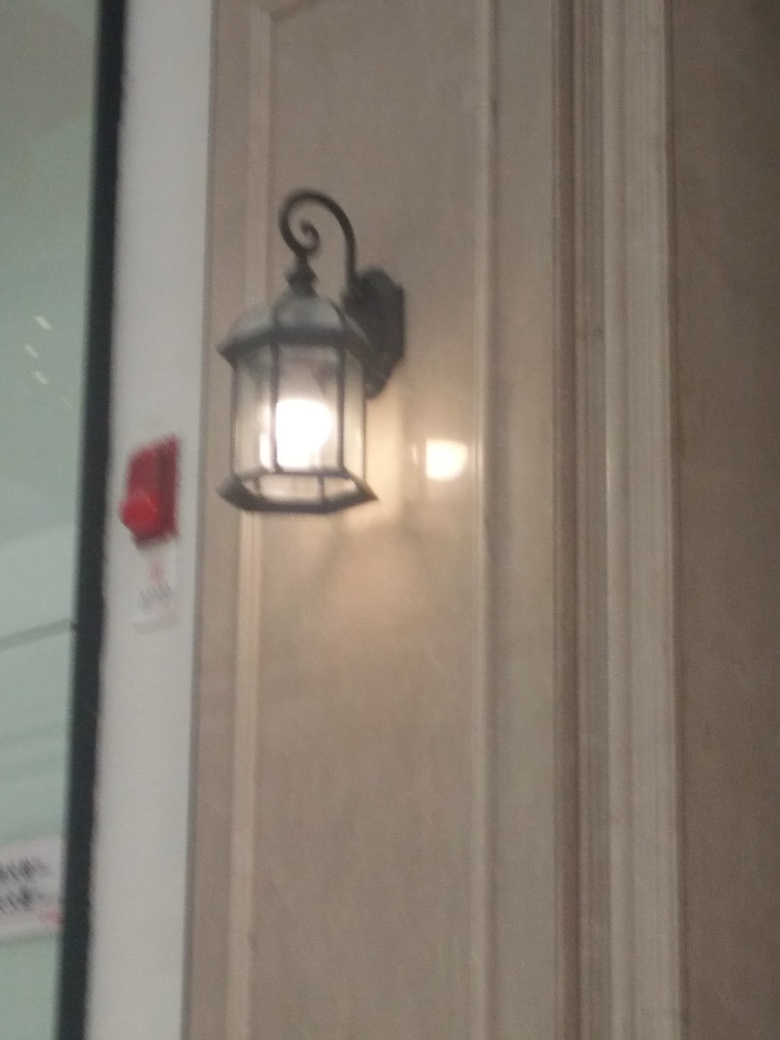Can you describe the style or era this lamp design might be from? The lamp has a classic design, likely inspired by traditional lanterns which might place it in a context reminiscent of the late 19th to early 20th century. It could be associated with Victorian or Edwardian styles, known for their ornate and decorative features. 